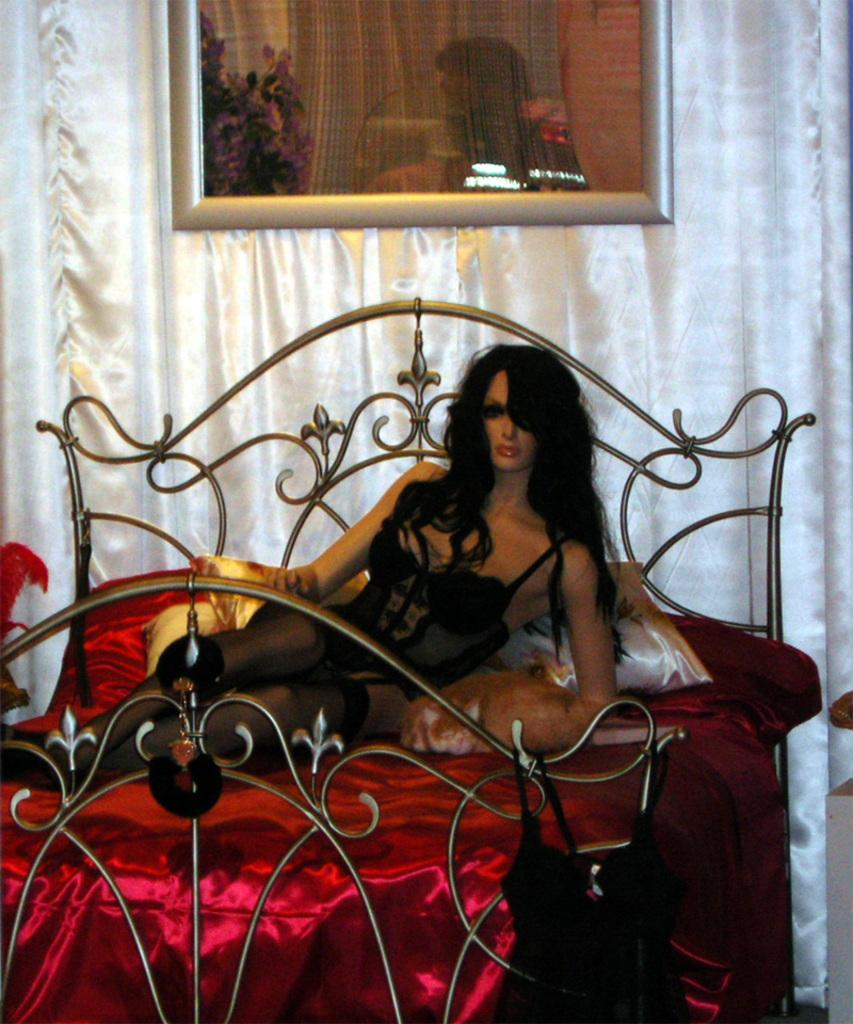What is placed on the bed in the image? There is a statue of a lady on the bed. What color is the bed cover? The bed has a red bed cover. What else can be seen on the bed? There are pillows on the bed. What is hanging on the wall in the image? There is a frame on the wall. What type of window treatment is visible in the background? There are white curtains in the background. What type of doctor is attending to the statue in the image? There is no doctor present in the image, and the statue is not being attended to by anyone. 